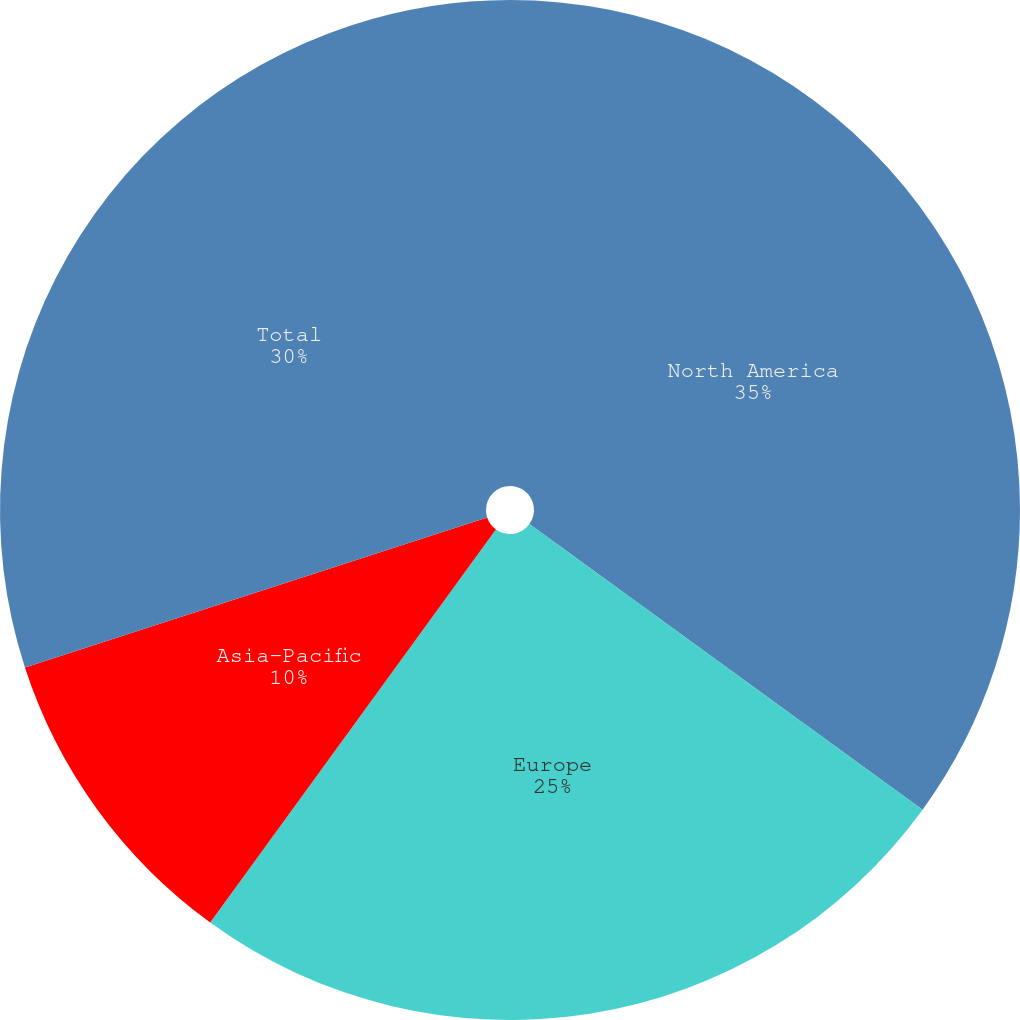Convert chart to OTSL. <chart><loc_0><loc_0><loc_500><loc_500><pie_chart><fcel>North America<fcel>Europe<fcel>Asia-Pacific<fcel>Total<nl><fcel>35.0%<fcel>25.0%<fcel>10.0%<fcel>30.0%<nl></chart> 